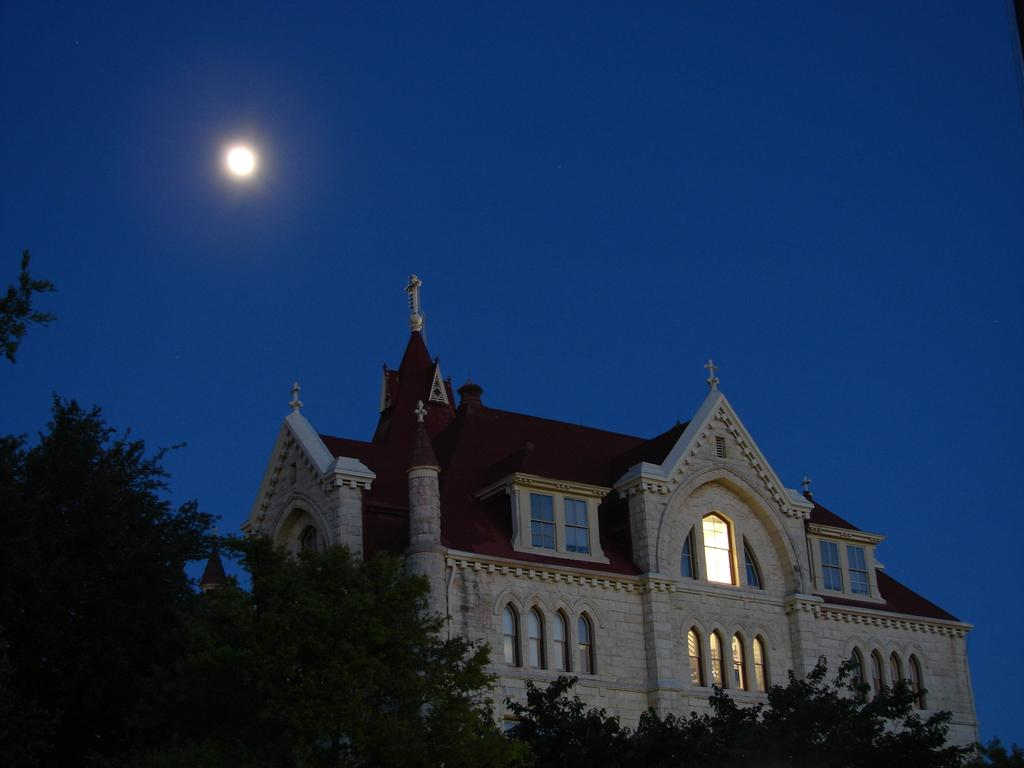What can be seen in the foreground of the picture? There are trees and a cathedral in the foreground of the picture. What is visible in the background of the image? The sky is visible in the image. Can you describe the celestial body present in the sky? The moon is present in the sky. What type of yarn is being sold at the store in the image? There is no store present in the image, and therefore no yarn can be observed. 